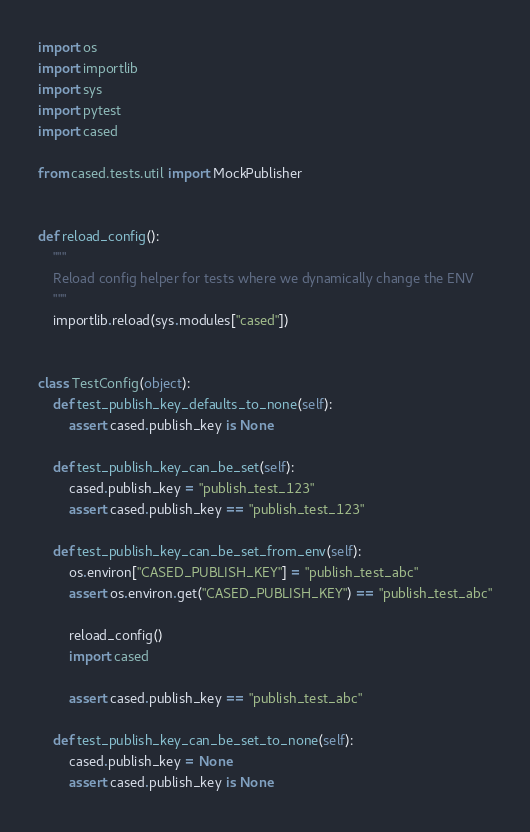Convert code to text. <code><loc_0><loc_0><loc_500><loc_500><_Python_>import os
import importlib
import sys
import pytest
import cased

from cased.tests.util import MockPublisher


def reload_config():
    """
    Reload config helper for tests where we dynamically change the ENV
    """
    importlib.reload(sys.modules["cased"])


class TestConfig(object):
    def test_publish_key_defaults_to_none(self):
        assert cased.publish_key is None

    def test_publish_key_can_be_set(self):
        cased.publish_key = "publish_test_123"
        assert cased.publish_key == "publish_test_123"

    def test_publish_key_can_be_set_from_env(self):
        os.environ["CASED_PUBLISH_KEY"] = "publish_test_abc"
        assert os.environ.get("CASED_PUBLISH_KEY") == "publish_test_abc"

        reload_config()
        import cased

        assert cased.publish_key == "publish_test_abc"

    def test_publish_key_can_be_set_to_none(self):
        cased.publish_key = None
        assert cased.publish_key is None
</code> 